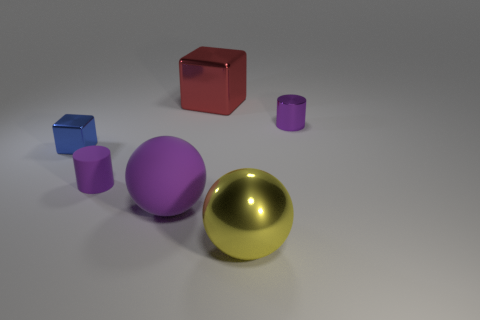Is the number of purple cylinders that are in front of the small blue cube greater than the number of purple matte cylinders that are left of the large purple sphere?
Your answer should be compact. No. How many other things are the same size as the yellow metallic ball?
Offer a terse response. 2. There is a large shiny thing behind the big yellow shiny sphere; does it have the same color as the large shiny ball?
Your response must be concise. No. Is the number of purple cylinders that are to the right of the small metallic cylinder greater than the number of tiny purple shiny cylinders?
Give a very brief answer. No. Are there any other things of the same color as the tiny cube?
Provide a succinct answer. No. What shape is the thing that is behind the cylinder that is right of the yellow thing?
Ensure brevity in your answer.  Cube. Are there more large matte things than big gray spheres?
Offer a terse response. Yes. How many things are both in front of the tiny purple matte object and to the left of the big purple object?
Provide a short and direct response. 0. There is a purple cylinder left of the big rubber ball; how many blue shiny cubes are to the right of it?
Offer a very short reply. 0. What number of objects are tiny matte cylinders in front of the small blue metal thing or tiny objects to the right of the purple rubber ball?
Your answer should be compact. 2. 